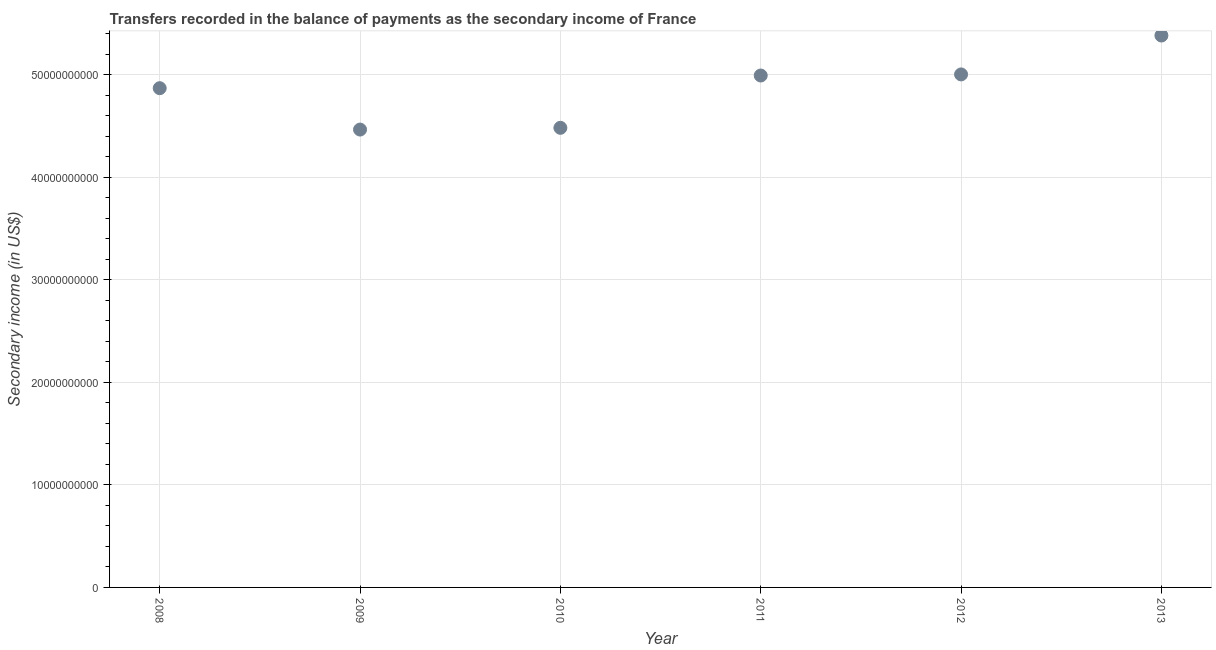What is the amount of secondary income in 2008?
Keep it short and to the point. 4.87e+1. Across all years, what is the maximum amount of secondary income?
Provide a short and direct response. 5.38e+1. Across all years, what is the minimum amount of secondary income?
Provide a short and direct response. 4.46e+1. In which year was the amount of secondary income maximum?
Keep it short and to the point. 2013. What is the sum of the amount of secondary income?
Provide a short and direct response. 2.92e+11. What is the difference between the amount of secondary income in 2010 and 2013?
Offer a very short reply. -9.00e+09. What is the average amount of secondary income per year?
Your response must be concise. 4.86e+1. What is the median amount of secondary income?
Your answer should be very brief. 4.93e+1. What is the ratio of the amount of secondary income in 2011 to that in 2012?
Offer a very short reply. 1. Is the amount of secondary income in 2009 less than that in 2011?
Provide a succinct answer. Yes. Is the difference between the amount of secondary income in 2009 and 2011 greater than the difference between any two years?
Give a very brief answer. No. What is the difference between the highest and the second highest amount of secondary income?
Ensure brevity in your answer.  3.79e+09. What is the difference between the highest and the lowest amount of secondary income?
Offer a terse response. 9.17e+09. Does the amount of secondary income monotonically increase over the years?
Your response must be concise. No. Does the graph contain any zero values?
Make the answer very short. No. What is the title of the graph?
Your answer should be very brief. Transfers recorded in the balance of payments as the secondary income of France. What is the label or title of the X-axis?
Offer a terse response. Year. What is the label or title of the Y-axis?
Make the answer very short. Secondary income (in US$). What is the Secondary income (in US$) in 2008?
Your answer should be very brief. 4.87e+1. What is the Secondary income (in US$) in 2009?
Provide a succinct answer. 4.46e+1. What is the Secondary income (in US$) in 2010?
Provide a short and direct response. 4.48e+1. What is the Secondary income (in US$) in 2011?
Make the answer very short. 4.99e+1. What is the Secondary income (in US$) in 2012?
Provide a succinct answer. 5.00e+1. What is the Secondary income (in US$) in 2013?
Give a very brief answer. 5.38e+1. What is the difference between the Secondary income (in US$) in 2008 and 2009?
Your response must be concise. 4.04e+09. What is the difference between the Secondary income (in US$) in 2008 and 2010?
Offer a terse response. 3.86e+09. What is the difference between the Secondary income (in US$) in 2008 and 2011?
Ensure brevity in your answer.  -1.23e+09. What is the difference between the Secondary income (in US$) in 2008 and 2012?
Provide a short and direct response. -1.34e+09. What is the difference between the Secondary income (in US$) in 2008 and 2013?
Your response must be concise. -5.13e+09. What is the difference between the Secondary income (in US$) in 2009 and 2010?
Keep it short and to the point. -1.71e+08. What is the difference between the Secondary income (in US$) in 2009 and 2011?
Offer a terse response. -5.27e+09. What is the difference between the Secondary income (in US$) in 2009 and 2012?
Provide a succinct answer. -5.38e+09. What is the difference between the Secondary income (in US$) in 2009 and 2013?
Your response must be concise. -9.17e+09. What is the difference between the Secondary income (in US$) in 2010 and 2011?
Make the answer very short. -5.10e+09. What is the difference between the Secondary income (in US$) in 2010 and 2012?
Offer a very short reply. -5.21e+09. What is the difference between the Secondary income (in US$) in 2010 and 2013?
Your response must be concise. -9.00e+09. What is the difference between the Secondary income (in US$) in 2011 and 2012?
Make the answer very short. -1.08e+08. What is the difference between the Secondary income (in US$) in 2011 and 2013?
Your answer should be compact. -3.90e+09. What is the difference between the Secondary income (in US$) in 2012 and 2013?
Ensure brevity in your answer.  -3.79e+09. What is the ratio of the Secondary income (in US$) in 2008 to that in 2009?
Your answer should be very brief. 1.09. What is the ratio of the Secondary income (in US$) in 2008 to that in 2010?
Give a very brief answer. 1.09. What is the ratio of the Secondary income (in US$) in 2008 to that in 2012?
Provide a succinct answer. 0.97. What is the ratio of the Secondary income (in US$) in 2008 to that in 2013?
Offer a very short reply. 0.91. What is the ratio of the Secondary income (in US$) in 2009 to that in 2011?
Offer a very short reply. 0.89. What is the ratio of the Secondary income (in US$) in 2009 to that in 2012?
Provide a succinct answer. 0.89. What is the ratio of the Secondary income (in US$) in 2009 to that in 2013?
Provide a succinct answer. 0.83. What is the ratio of the Secondary income (in US$) in 2010 to that in 2011?
Offer a very short reply. 0.9. What is the ratio of the Secondary income (in US$) in 2010 to that in 2012?
Your answer should be very brief. 0.9. What is the ratio of the Secondary income (in US$) in 2010 to that in 2013?
Ensure brevity in your answer.  0.83. What is the ratio of the Secondary income (in US$) in 2011 to that in 2013?
Your answer should be compact. 0.93. 